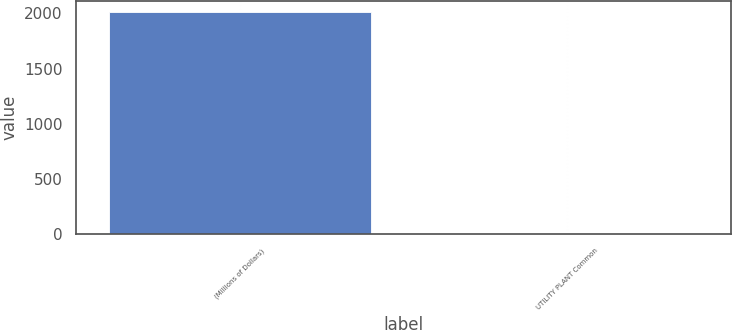<chart> <loc_0><loc_0><loc_500><loc_500><bar_chart><fcel>(Millions of Dollars)<fcel>UTILITY PLANT Common<nl><fcel>2014<fcel>3<nl></chart> 